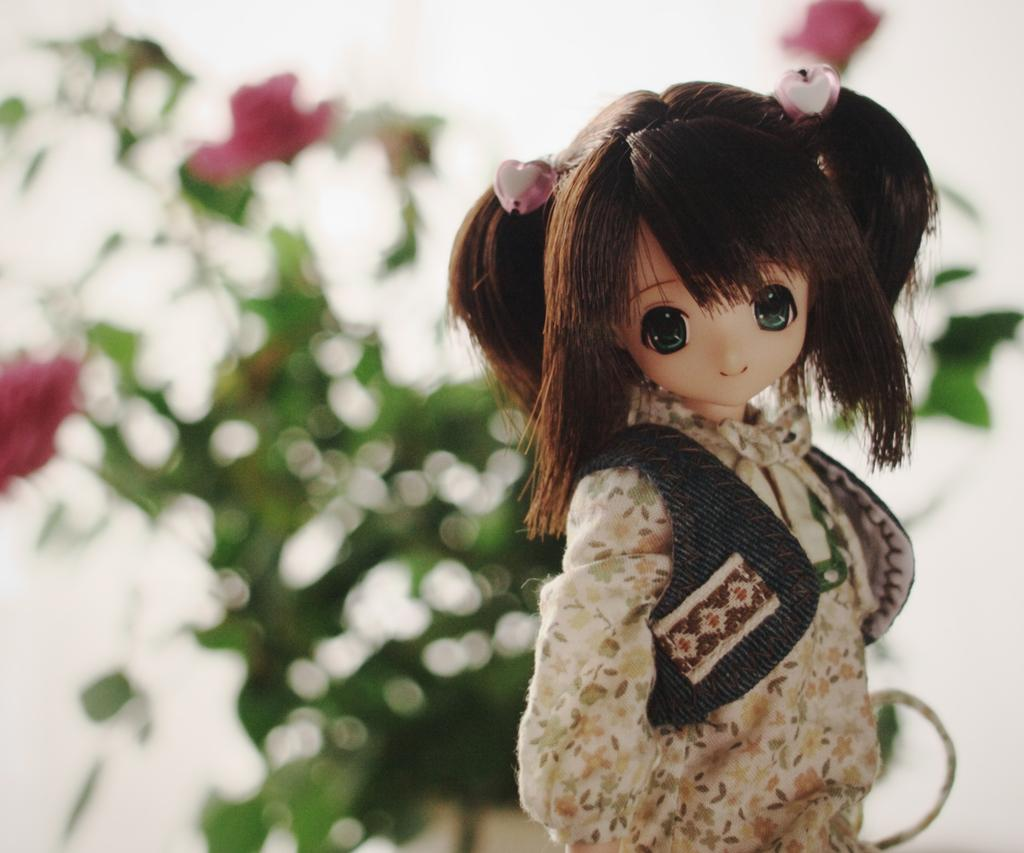What is the main subject in the middle of the image? There is a small girl toy in the middle of the image. What can be seen in the background of the image? There is a plant in the background of the image. What is special about the flowers on the plant? The flowers on the plant have a pink color. How many clocks are hanging on the wall in the image? There are no clocks visible in the image. Is there a fire burning in the image? There is no fire present in the image. 